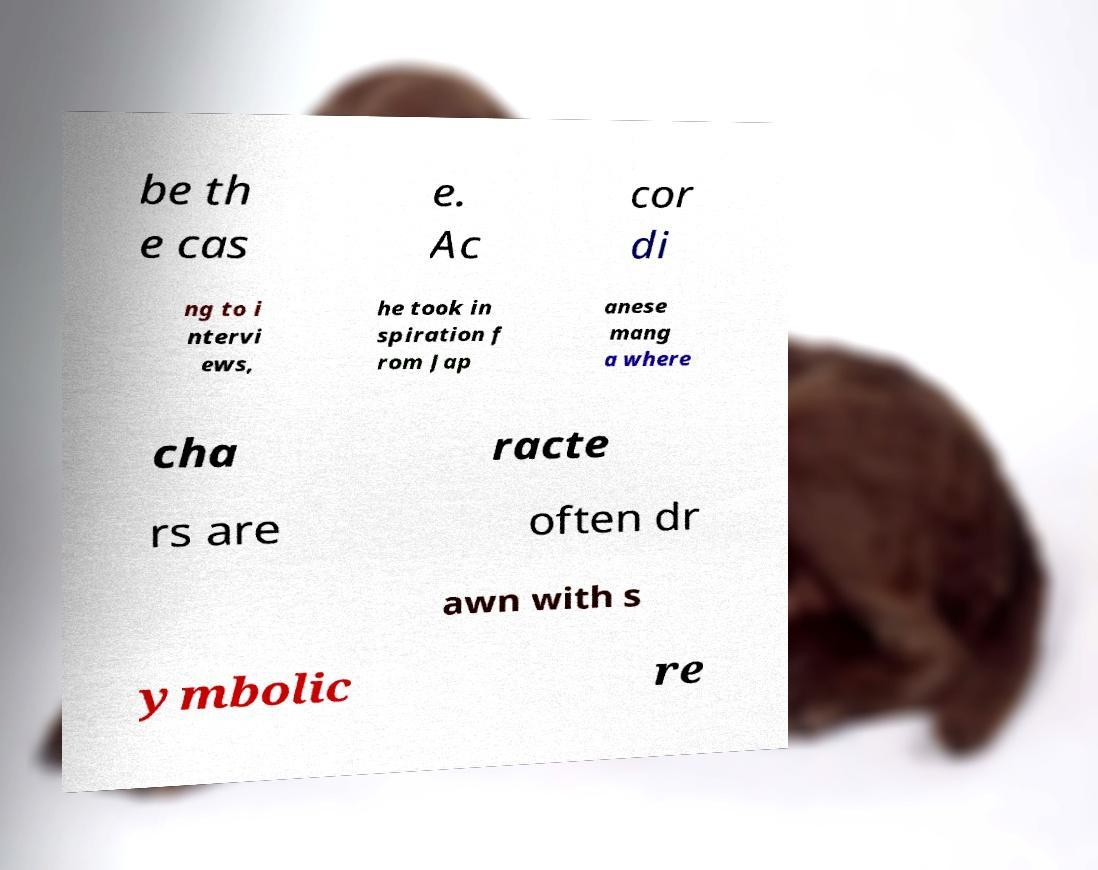There's text embedded in this image that I need extracted. Can you transcribe it verbatim? be th e cas e. Ac cor di ng to i ntervi ews, he took in spiration f rom Jap anese mang a where cha racte rs are often dr awn with s ymbolic re 